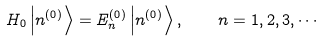Convert formula to latex. <formula><loc_0><loc_0><loc_500><loc_500>H _ { 0 } \left | n ^ { ( 0 ) } \right \rangle = E _ { n } ^ { ( 0 ) } \left | n ^ { ( 0 ) } \right \rangle , \quad n = 1 , 2 , 3 , \cdots</formula> 